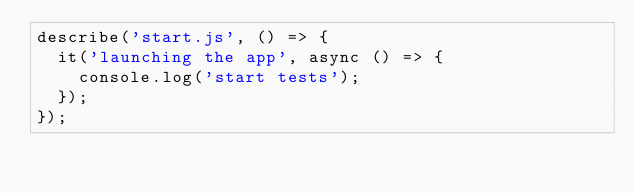<code> <loc_0><loc_0><loc_500><loc_500><_JavaScript_>describe('start.js', () => {
  it('launching the app', async () => {
    console.log('start tests');
  });
});
</code> 